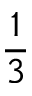Convert formula to latex. <formula><loc_0><loc_0><loc_500><loc_500>\frac { 1 } { 3 }</formula> 